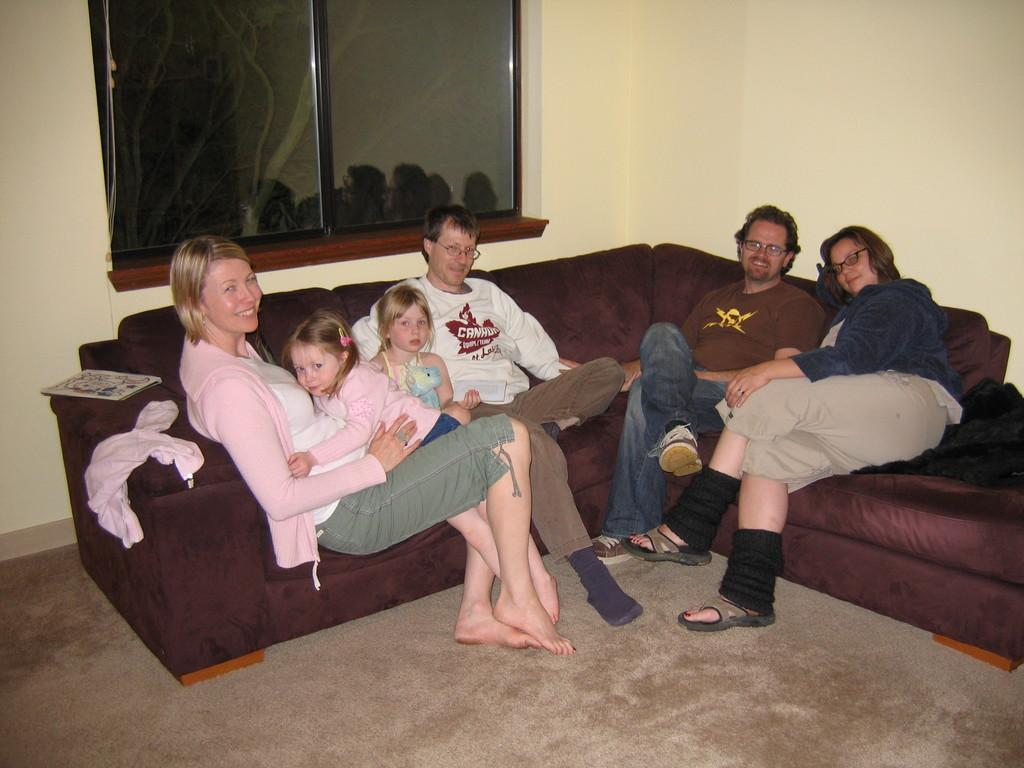How many people are in the image? There are two women, two kids, and two men in the image, making a total of six people. What are the people doing in the image? The people are sitting on a couch. What can be seen in the background of the image? There is a window and a wall in the background of the image. What type of bee can be seen buzzing around the window in the image? There is no bee present in the image; it only features people sitting on a couch and a window in the background. Are the two women in the image sisters? The provided facts do not mention any familial relationship between the two women, so we cannot determine if they are sisters or not. 